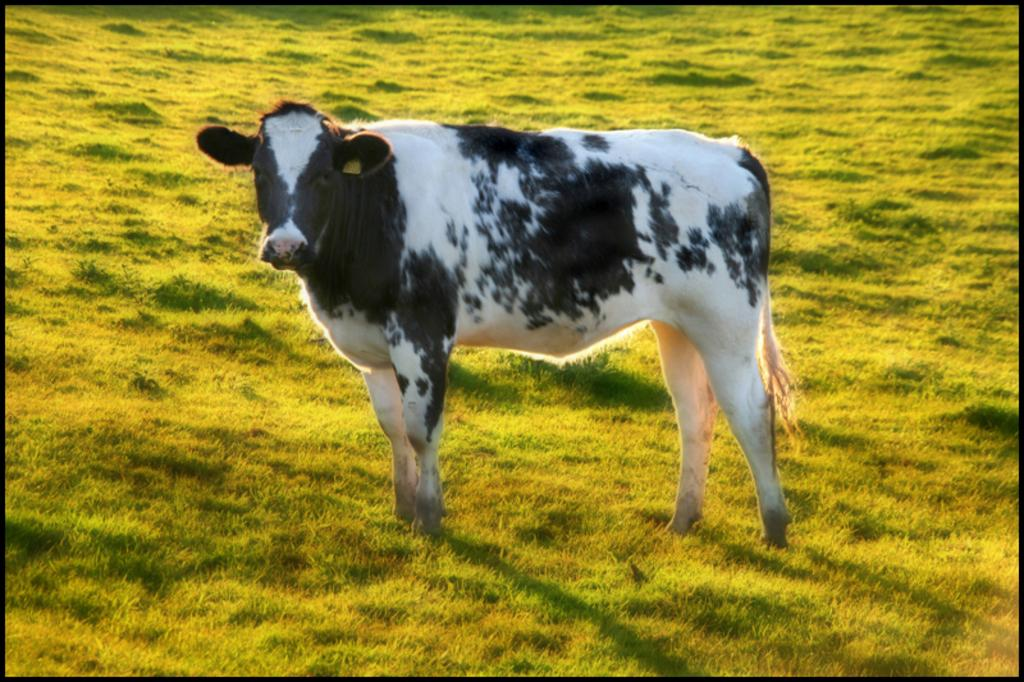What animal is in the picture? There is a cow in the picture. What is the cow standing on? The cow is on the grass. What color is the cow in the picture? The cow is in black and white color. What song is the cow singing in the picture? Cows do not sing songs, so there is no song being sung by the cow in the image. 